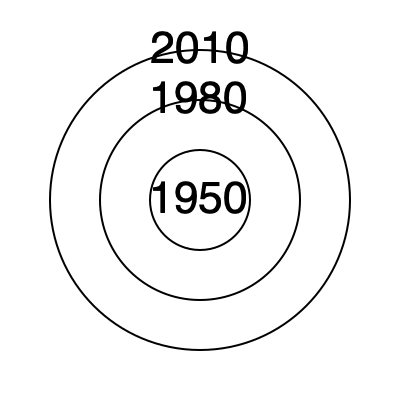The concentric circles represent Little Rock's city boundaries in different years. If the area of the innermost circle (1950) is 100 square miles, approximately how many square miles did the city cover in 2010? To solve this problem, we need to follow these steps:

1. Observe that the radius of each circle increases by the same amount from the center.
2. The outermost circle (2010) has a radius 3 times larger than the innermost circle (1950).
3. Recall that the area of a circle is given by the formula $A = \pi r^2$.
4. If we denote the radius of the 1950 circle as $r$, then:
   Area of 1950 circle: $A_1 = \pi r^2 = 100$ sq miles
5. The radius of the 2010 circle is $3r$, so its area is:
   Area of 2010 circle: $A_2 = \pi (3r)^2 = 9\pi r^2 = 9A_1$
6. Therefore, the area of the 2010 circle is 9 times the area of the 1950 circle.
7. Calculate: $9 \times 100 = 900$ sq miles
Answer: 900 square miles 